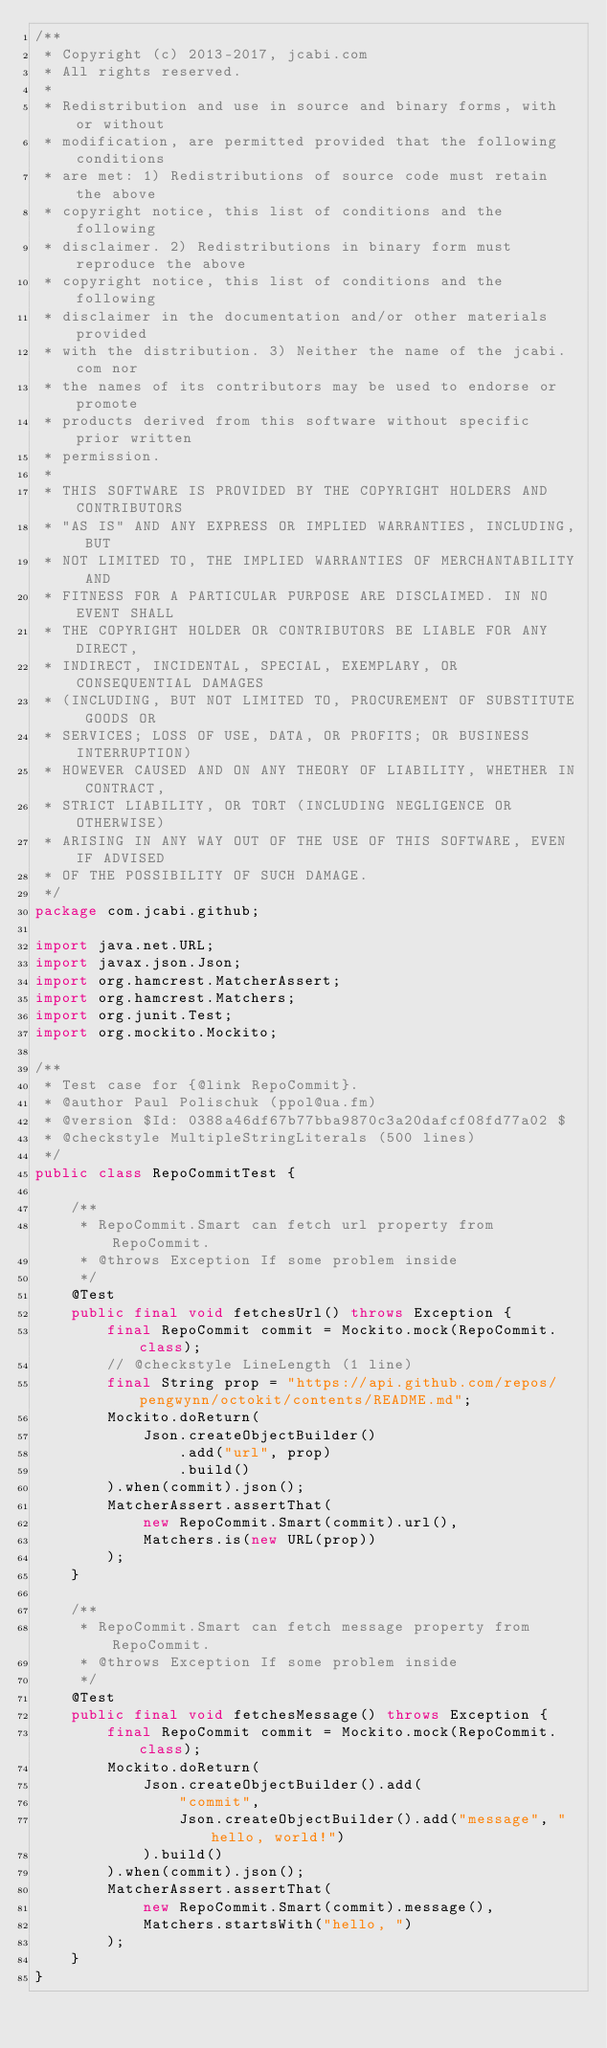<code> <loc_0><loc_0><loc_500><loc_500><_Java_>/**
 * Copyright (c) 2013-2017, jcabi.com
 * All rights reserved.
 *
 * Redistribution and use in source and binary forms, with or without
 * modification, are permitted provided that the following conditions
 * are met: 1) Redistributions of source code must retain the above
 * copyright notice, this list of conditions and the following
 * disclaimer. 2) Redistributions in binary form must reproduce the above
 * copyright notice, this list of conditions and the following
 * disclaimer in the documentation and/or other materials provided
 * with the distribution. 3) Neither the name of the jcabi.com nor
 * the names of its contributors may be used to endorse or promote
 * products derived from this software without specific prior written
 * permission.
 *
 * THIS SOFTWARE IS PROVIDED BY THE COPYRIGHT HOLDERS AND CONTRIBUTORS
 * "AS IS" AND ANY EXPRESS OR IMPLIED WARRANTIES, INCLUDING, BUT
 * NOT LIMITED TO, THE IMPLIED WARRANTIES OF MERCHANTABILITY AND
 * FITNESS FOR A PARTICULAR PURPOSE ARE DISCLAIMED. IN NO EVENT SHALL
 * THE COPYRIGHT HOLDER OR CONTRIBUTORS BE LIABLE FOR ANY DIRECT,
 * INDIRECT, INCIDENTAL, SPECIAL, EXEMPLARY, OR CONSEQUENTIAL DAMAGES
 * (INCLUDING, BUT NOT LIMITED TO, PROCUREMENT OF SUBSTITUTE GOODS OR
 * SERVICES; LOSS OF USE, DATA, OR PROFITS; OR BUSINESS INTERRUPTION)
 * HOWEVER CAUSED AND ON ANY THEORY OF LIABILITY, WHETHER IN CONTRACT,
 * STRICT LIABILITY, OR TORT (INCLUDING NEGLIGENCE OR OTHERWISE)
 * ARISING IN ANY WAY OUT OF THE USE OF THIS SOFTWARE, EVEN IF ADVISED
 * OF THE POSSIBILITY OF SUCH DAMAGE.
 */
package com.jcabi.github;

import java.net.URL;
import javax.json.Json;
import org.hamcrest.MatcherAssert;
import org.hamcrest.Matchers;
import org.junit.Test;
import org.mockito.Mockito;

/**
 * Test case for {@link RepoCommit}.
 * @author Paul Polischuk (ppol@ua.fm)
 * @version $Id: 0388a46df67b77bba9870c3a20dafcf08fd77a02 $
 * @checkstyle MultipleStringLiterals (500 lines)
 */
public class RepoCommitTest {

    /**
     * RepoCommit.Smart can fetch url property from RepoCommit.
     * @throws Exception If some problem inside
     */
    @Test
    public final void fetchesUrl() throws Exception {
        final RepoCommit commit = Mockito.mock(RepoCommit.class);
        // @checkstyle LineLength (1 line)
        final String prop = "https://api.github.com/repos/pengwynn/octokit/contents/README.md";
        Mockito.doReturn(
            Json.createObjectBuilder()
                .add("url", prop)
                .build()
        ).when(commit).json();
        MatcherAssert.assertThat(
            new RepoCommit.Smart(commit).url(),
            Matchers.is(new URL(prop))
        );
    }

    /**
     * RepoCommit.Smart can fetch message property from RepoCommit.
     * @throws Exception If some problem inside
     */
    @Test
    public final void fetchesMessage() throws Exception {
        final RepoCommit commit = Mockito.mock(RepoCommit.class);
        Mockito.doReturn(
            Json.createObjectBuilder().add(
                "commit",
                Json.createObjectBuilder().add("message", "hello, world!")
            ).build()
        ).when(commit).json();
        MatcherAssert.assertThat(
            new RepoCommit.Smart(commit).message(),
            Matchers.startsWith("hello, ")
        );
    }
}
</code> 